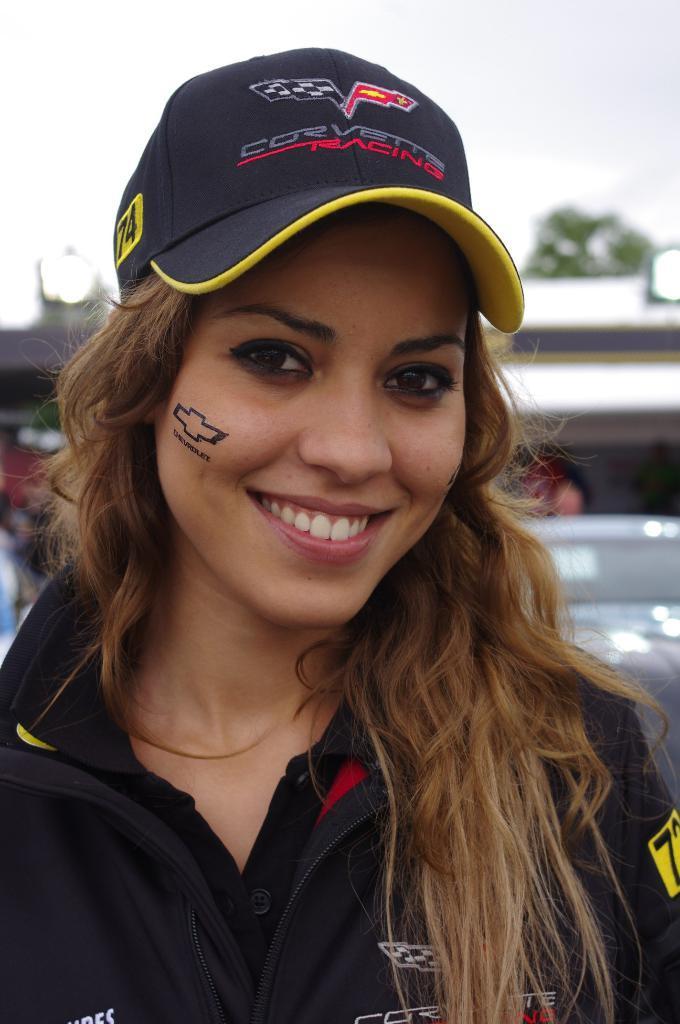Can you describe this image briefly? This image consists of a woman wearing blue T-shirt and a black cap. In the background, there is a sky. 